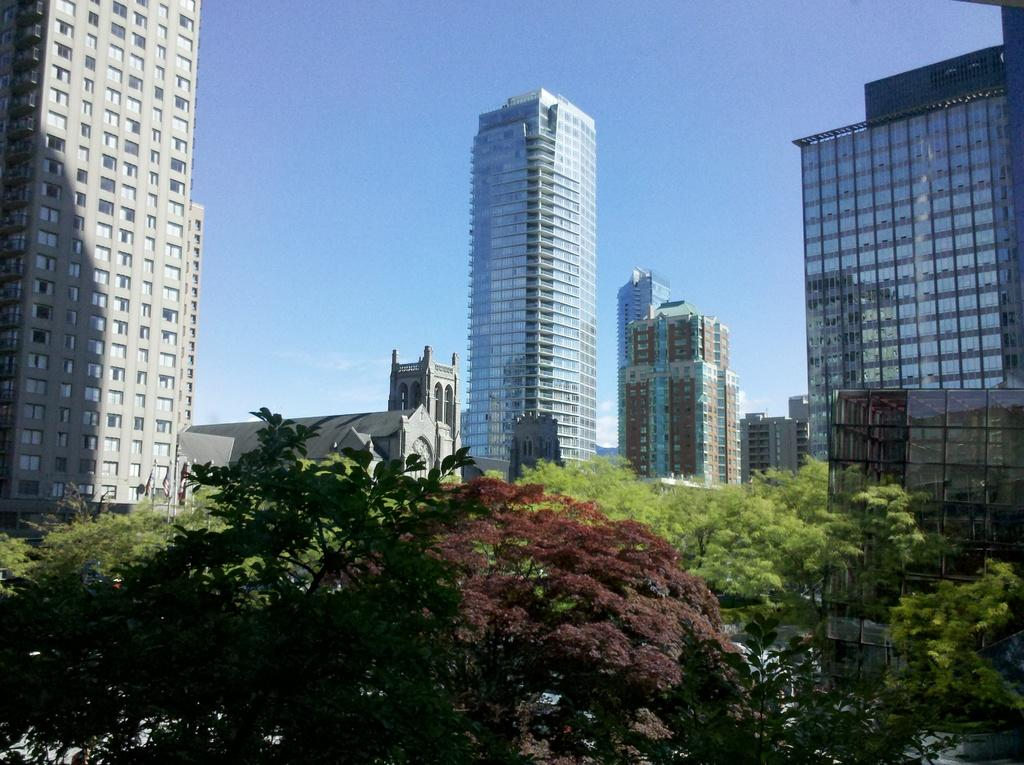What type of structures are visible in the image? There are tall buildings in the image. What is located in front of the buildings? There are trees in front of the buildings. What is visible at the top of the image? The sky is visible at the top of the image. Where is the cellar located in the image? There is no cellar present in the image. What type of education is being offered in the image? There is no indication of education in the image. 